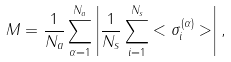<formula> <loc_0><loc_0><loc_500><loc_500>M = \frac { 1 } { N _ { a } } \sum _ { \alpha = 1 } ^ { N _ { a } } \left | \frac { 1 } { N _ { s } } \sum _ { i = 1 } ^ { N _ { s } } < \sigma _ { i } ^ { ( \alpha ) } > \right | ,</formula> 